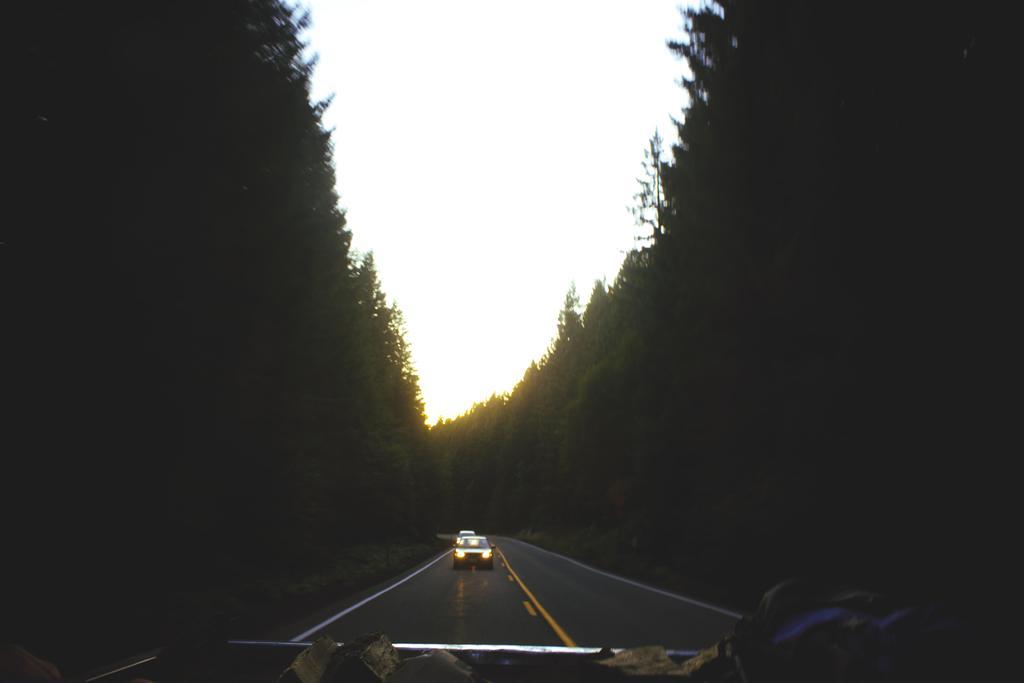How would you summarize this image in a sentence or two? In this image, there is a car on the road which is in between trees. There is sky at the top of the image. 